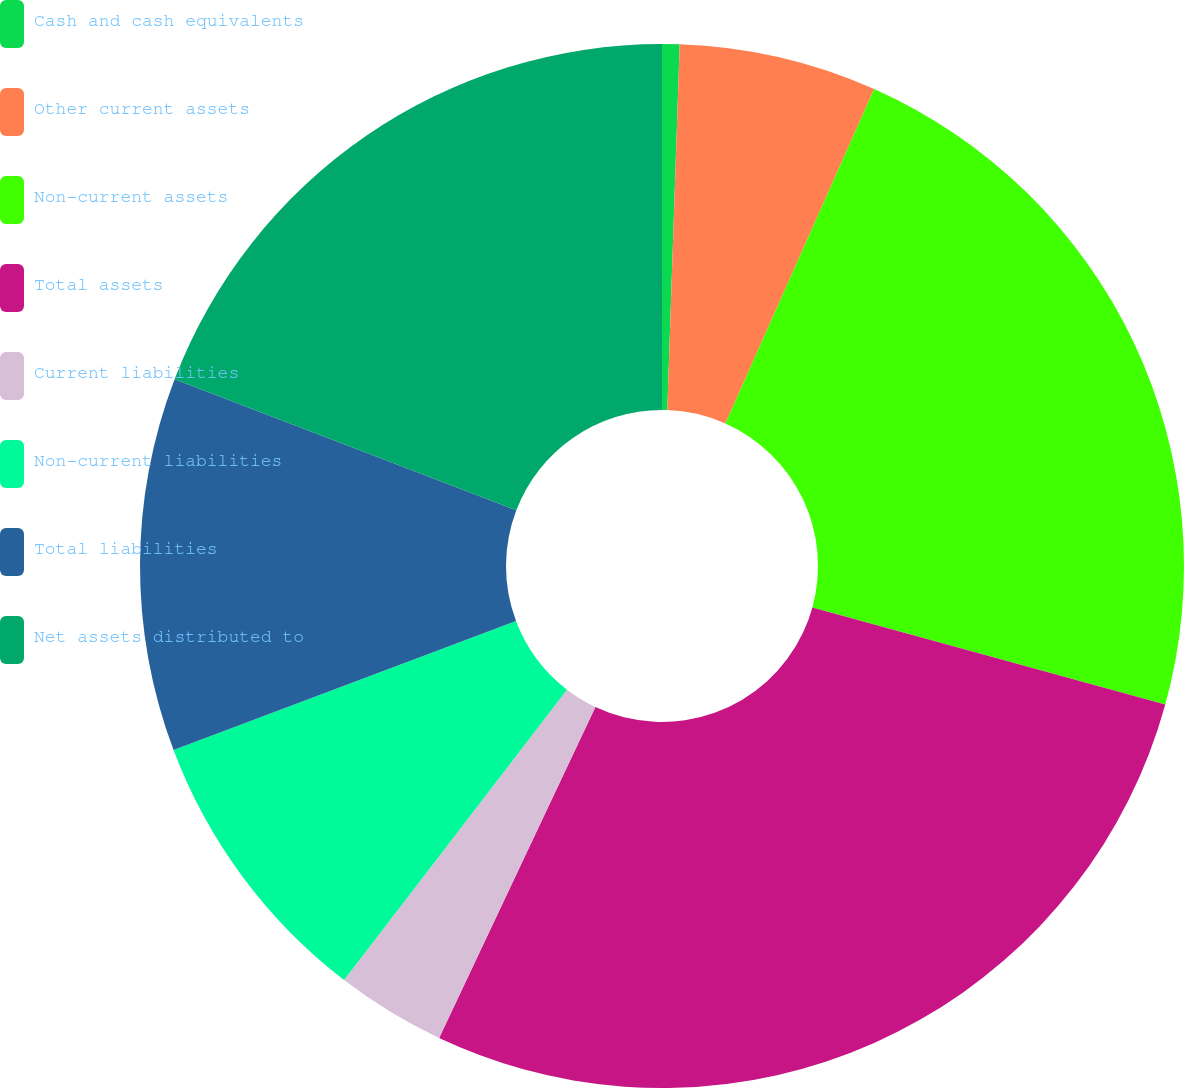<chart> <loc_0><loc_0><loc_500><loc_500><pie_chart><fcel>Cash and cash equivalents<fcel>Other current assets<fcel>Non-current assets<fcel>Total assets<fcel>Current liabilities<fcel>Non-current liabilities<fcel>Total liabilities<fcel>Net assets distributed to<nl><fcel>0.54%<fcel>6.12%<fcel>22.61%<fcel>27.74%<fcel>3.4%<fcel>8.84%<fcel>11.56%<fcel>19.17%<nl></chart> 